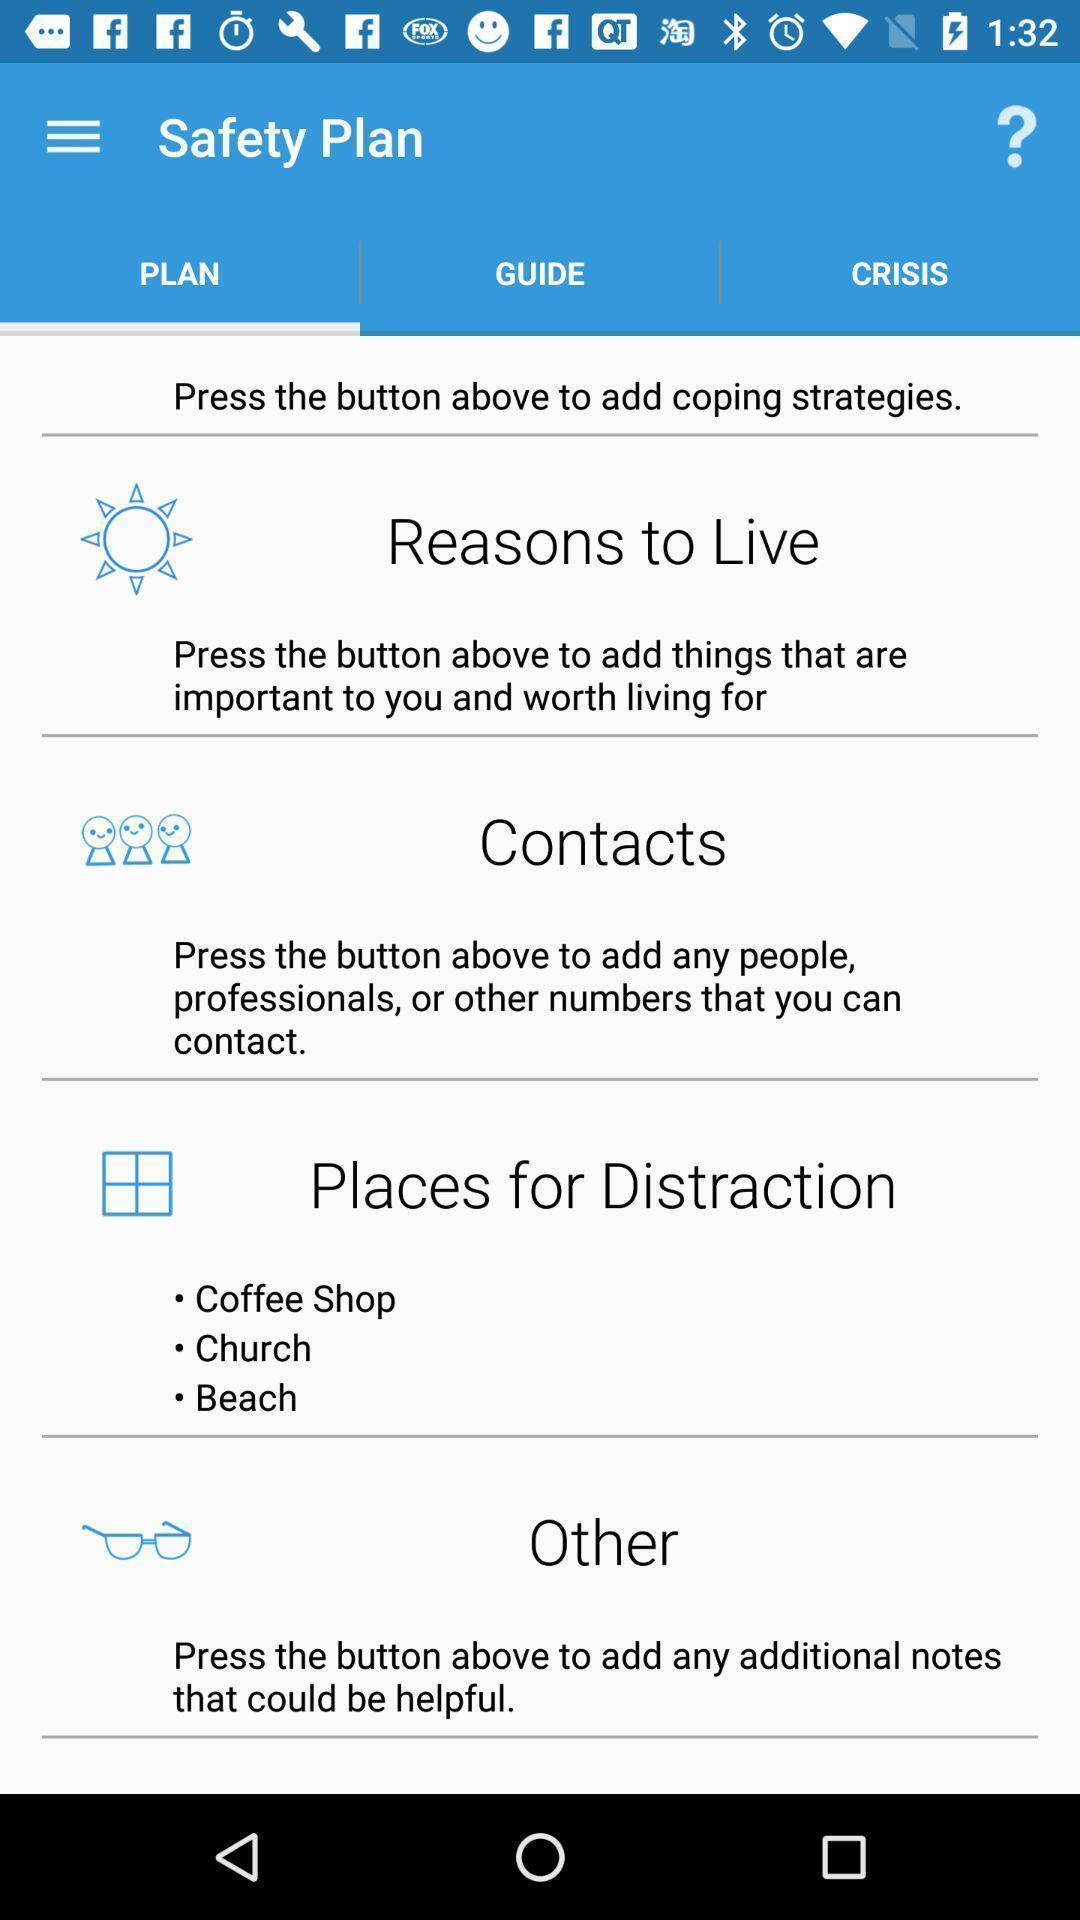Describe the key features of this screenshot. Page showing information about application. 